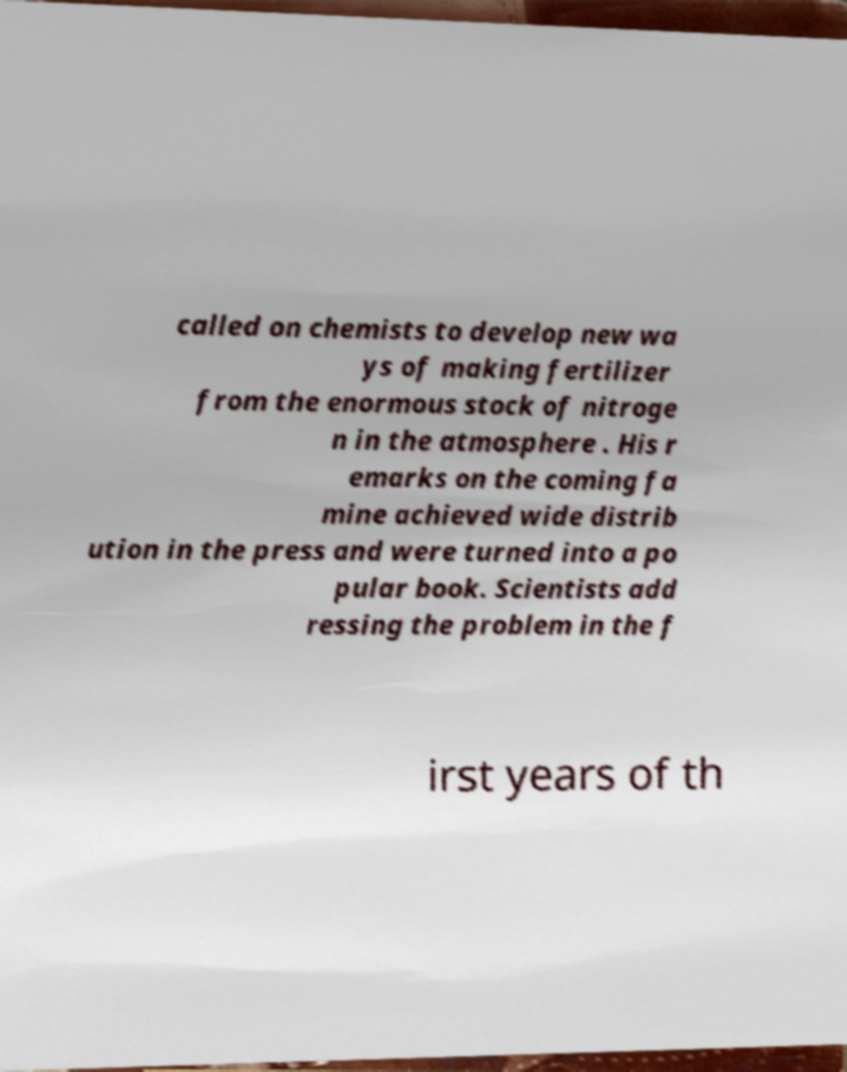Please identify and transcribe the text found in this image. called on chemists to develop new wa ys of making fertilizer from the enormous stock of nitroge n in the atmosphere . His r emarks on the coming fa mine achieved wide distrib ution in the press and were turned into a po pular book. Scientists add ressing the problem in the f irst years of th 